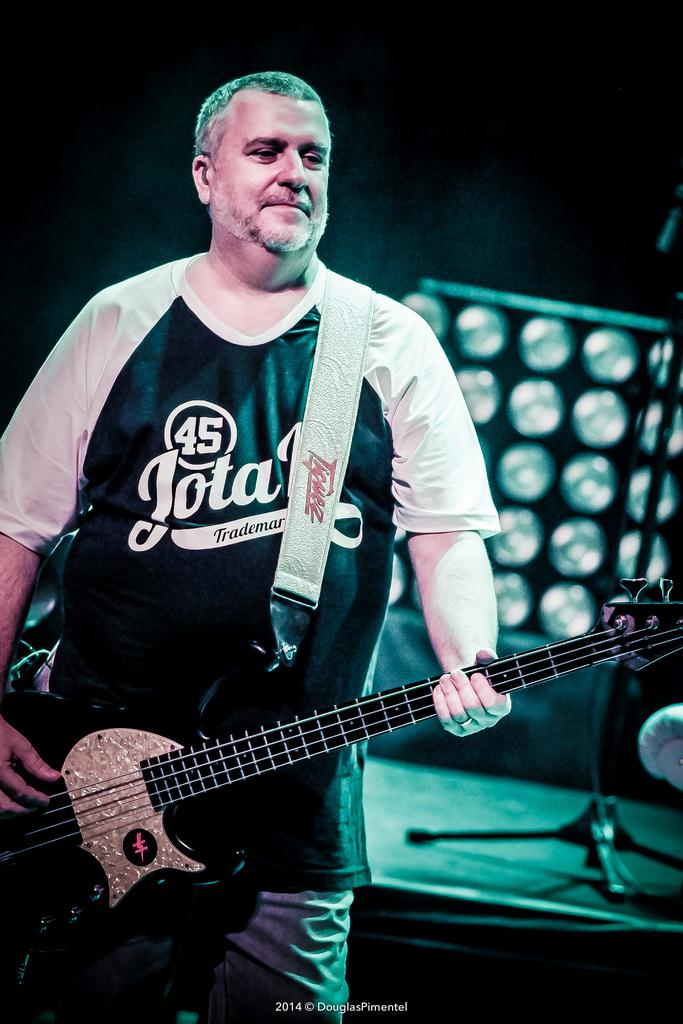What is the main subject of the image? The main subject of the image is a person standing. What is the person holding in his hands? The person is holding a guitar in his hands. What type of bear can be seen playing the guitar in the image? There is no bear present in the image, and therefore no such activity can be observed. What type of adjustment is being made to the guitar in the image? There is no adjustment being made to the guitar in the image; the person is simply holding it. 